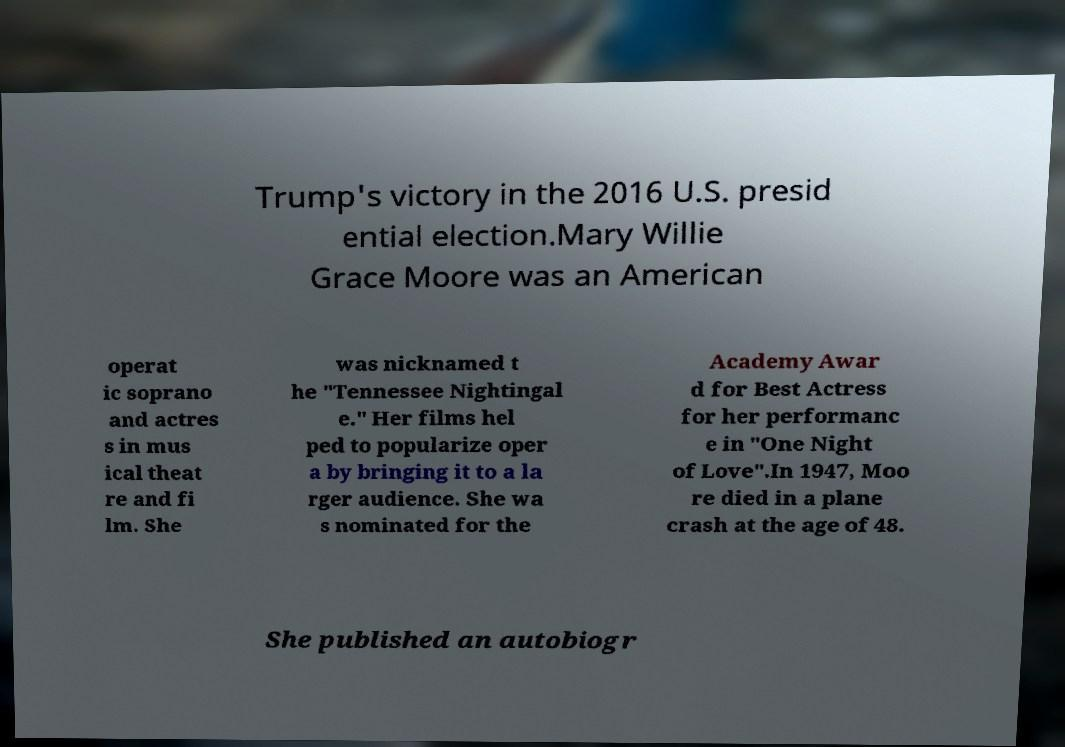What messages or text are displayed in this image? I need them in a readable, typed format. Trump's victory in the 2016 U.S. presid ential election.Mary Willie Grace Moore was an American operat ic soprano and actres s in mus ical theat re and fi lm. She was nicknamed t he "Tennessee Nightingal e." Her films hel ped to popularize oper a by bringing it to a la rger audience. She wa s nominated for the Academy Awar d for Best Actress for her performanc e in "One Night of Love".In 1947, Moo re died in a plane crash at the age of 48. She published an autobiogr 